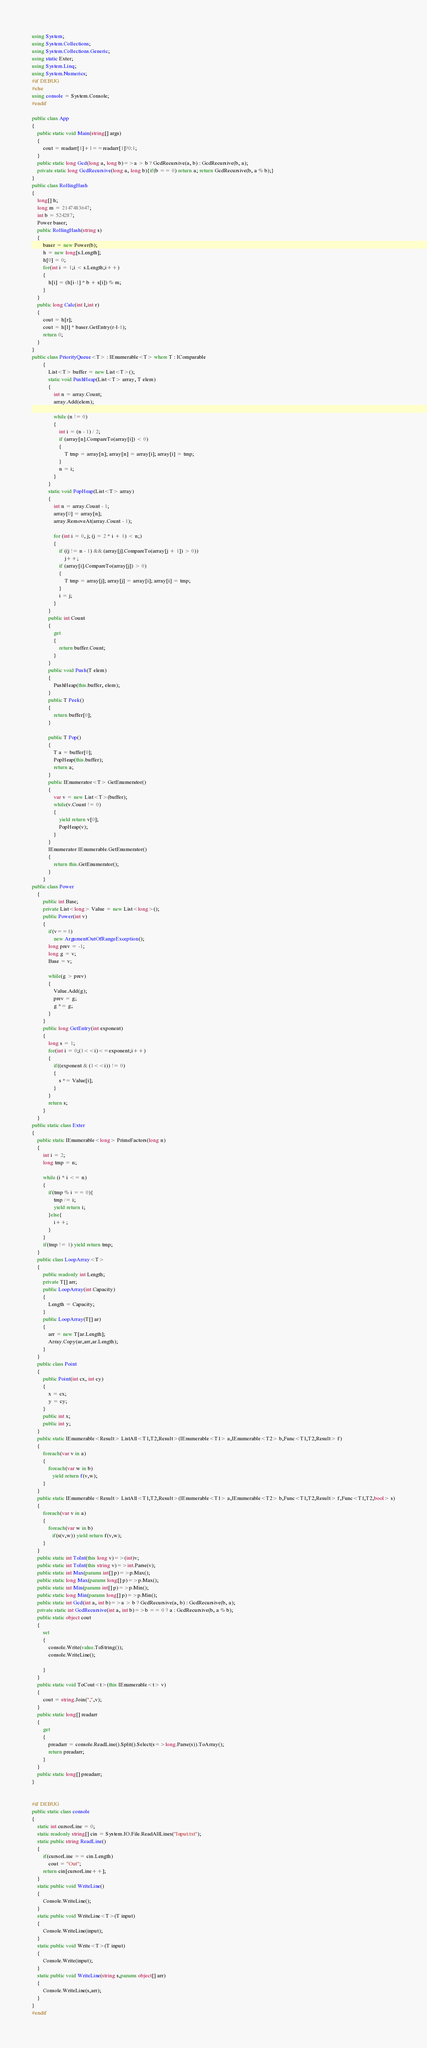Convert code to text. <code><loc_0><loc_0><loc_500><loc_500><_C#_>using System;
using System.Collections;
using System.Collections.Generic;
using static Exter;
using System.Linq;
using System.Numerics;
#if DEBUG
#else
using console = System.Console;
#endif

public class App
{
    public static void Main(string[] args)
    {
        cout = readarr[1]+1==readarr[1]?0:1;
    }
    public static long Gcd(long a, long b)=>a > b ? GcdRecursive(a, b) : GcdRecursive(b, a);
    private static long GcdRecursive(long a, long b){if(b == 0) return a; return GcdRecursive(b, a % b);}
}
public class RollingHash
{
    long[] h;
    long m = 2147483647;
    int b = 524287;
    Power baser;
    public RollingHash(string s)
    {
        baser = new Power(b);
        h = new long[s.Length];
        h[0] = 0;
        for(int i = 1;i < s.Length;i++)
        {
            h[i] = (h[i-1] * b + s[i]) % m;
        }
    }
    public long Calc(int l,int r)
    {
        cout = h[r];
        cout = h[l] * baser.GetEntry(r-l-1);
        return 0;
    }
}
public class PriorityQueue<T> : IEnumerable<T> where T : IComparable
        {
            List<T> buffer = new List<T>();
            static void PushHeap(List<T> array, T elem)
            {
                int n = array.Count;
                array.Add(elem);
 
                while (n != 0)
                {
                    int i = (n - 1) / 2;
                    if (array[n].CompareTo(array[i]) < 0)
                    {
                        T tmp = array[n]; array[n] = array[i]; array[i] = tmp;
                    }
                    n = i;
                }
            }
            static void PopHeap(List<T> array)
            {
                int n = array.Count - 1;
                array[0] = array[n];
                array.RemoveAt(array.Count - 1);
 
                for (int i = 0, j; (j = 2 * i + 1) < n;)
                {
                    if ((j != n - 1) && (array[j].CompareTo(array[j + 1]) > 0))
                        j++;
                    if (array[i].CompareTo(array[j]) > 0)
                    {
                        T tmp = array[j]; array[j] = array[i]; array[i] = tmp;
                    }
                    i = j;
                }
            }
            public int Count
            {
                get
                {
                    return buffer.Count;
                }
            }
            public void Push(T elem)
            {
                PushHeap(this.buffer, elem);
            }
            public T Peek()
            {
                return buffer[0];
            }
 
            public T Pop()
            {
                T a = buffer[0];
                PopHeap(this.buffer);
                return a;
            }
            public IEnumerator<T> GetEnumerator()
            {
                var v = new List<T>(buffer);
                while(v.Count != 0)
                {
                    yield return v[0];
                    PopHeap(v);
                }
            }
            IEnumerator IEnumerable.GetEnumerator()
            {
                return this.GetEnumerator();
            }
        }
public class Power
    {
        public int Base;
        private List<long> Value = new List<long>();
        public Power(int v)
        {
            if(v==1)
                new ArgumentOutOfRangeException();
            long prev = -1;
            long g = v;
            Base = v;
            
            while(g > prev)
            {
                Value.Add(g);
                prev = g;
                g *= g;
            }
        }
        public long GetEntry(int exponent)
        {
            long s = 1;
            for(int i = 0;(1<<i)<=exponent;i++)
            {
                if((exponent & (1<<i)) != 0)
                {
                    s *= Value[i];
                }
            }
            return s;
        }
    }
public static class Exter
{
    public static IEnumerable<long> PrimeFactors(long n)
    {
        int i = 2;
        long tmp = n;

        while (i * i <= n)
        {
            if(tmp % i == 0){
                tmp /= i;
                yield return i;
            }else{
                i++;
            }
        }
        if(tmp != 1) yield return tmp;
    }
    public class LoopArray<T>
    {
        public readonly int Length;
        private T[] arr;
        public LoopArray(int Capacity)
        {
            Length = Capacity;
        }
        public LoopArray(T[] ar)
        {
            arr = new T[ar.Length];
            Array.Copy(ar,arr,ar.Length);
        }
    }
    public class Point
    {
        public Point(int cx, int cy)
        {
            x = cx;
            y = cy;
        }
        public int x;
        public int y;
    }
    public static IEnumerable<Result> ListAll<T1,T2,Result>(IEnumerable<T1> a,IEnumerable<T2> b,Func<T1,T2,Result> f)
    {
        foreach(var v in a)
        {
            foreach(var w in b)
               yield return f(v,w);
        }
    }
    public static IEnumerable<Result> ListAll<T1,T2,Result>(IEnumerable<T1> a,IEnumerable<T2> b,Func<T1,T2,Result> f,Func<T1,T2,bool> s)
    {
        foreach(var v in a)
        {
            foreach(var w in b)
               if(s(v,w)) yield return f(v,w);
        }
    }
    public static int ToInt(this long v)=>(int)v;
    public static int ToInt(this string v)=>int.Parse(v);
    public static int Max(params int[] p)=>p.Max();
    public static long Max(params long[] p)=>p.Max();
    public static int Min(params int[] p)=>p.Min();
    public static long Min(params long[] p)=>p.Min();
    public static int Gcd(int a, int b)=>a > b ? GcdRecursive(a, b) : GcdRecursive(b, a);
    private static int GcdRecursive(int a, int b)=>b == 0 ? a : GcdRecursive(b, a % b);
    public static object cout
    {
        set
        {
            console.Write(value.ToString());
            console.WriteLine();
            
        }
    }
    public static void ToCout<t>(this IEnumerable<t> v)
    {
        cout = string.Join(",",v);
    }
    public static long[] readarr
    {
        get 
        {
            preadarr = console.ReadLine().Split().Select(s=>long.Parse(s)).ToArray();
            return preadarr;
        }
    }
    public static long[] preadarr;
}


#if DEBUG
public static class console
{
    static int cursorLine = 0;
    static readonly string[] cin = System.IO.File.ReadAllLines("Input.txt");
    static public string ReadLine()
    { 
        if(cursorLine == cin.Length)
            cout = "Out";
        return cin[cursorLine++];
    }
    static public void WriteLine()
    {
        Console.WriteLine();
    }
    static public void WriteLine<T>(T input)
    {
        Console.WriteLine(input);
    }
    static public void Write<T>(T input)
    {
        Console.Write(input);
    }
    static public void WriteLine(string s,params object[] arr)
    {
        Console.WriteLine(s,arr);
    }
}
#endif
</code> 